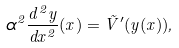Convert formula to latex. <formula><loc_0><loc_0><loc_500><loc_500>\alpha ^ { 2 } \frac { d ^ { 2 } y } { d x ^ { 2 } } ( x ) = \tilde { V } ^ { \prime } ( y ( x ) ) ,</formula> 